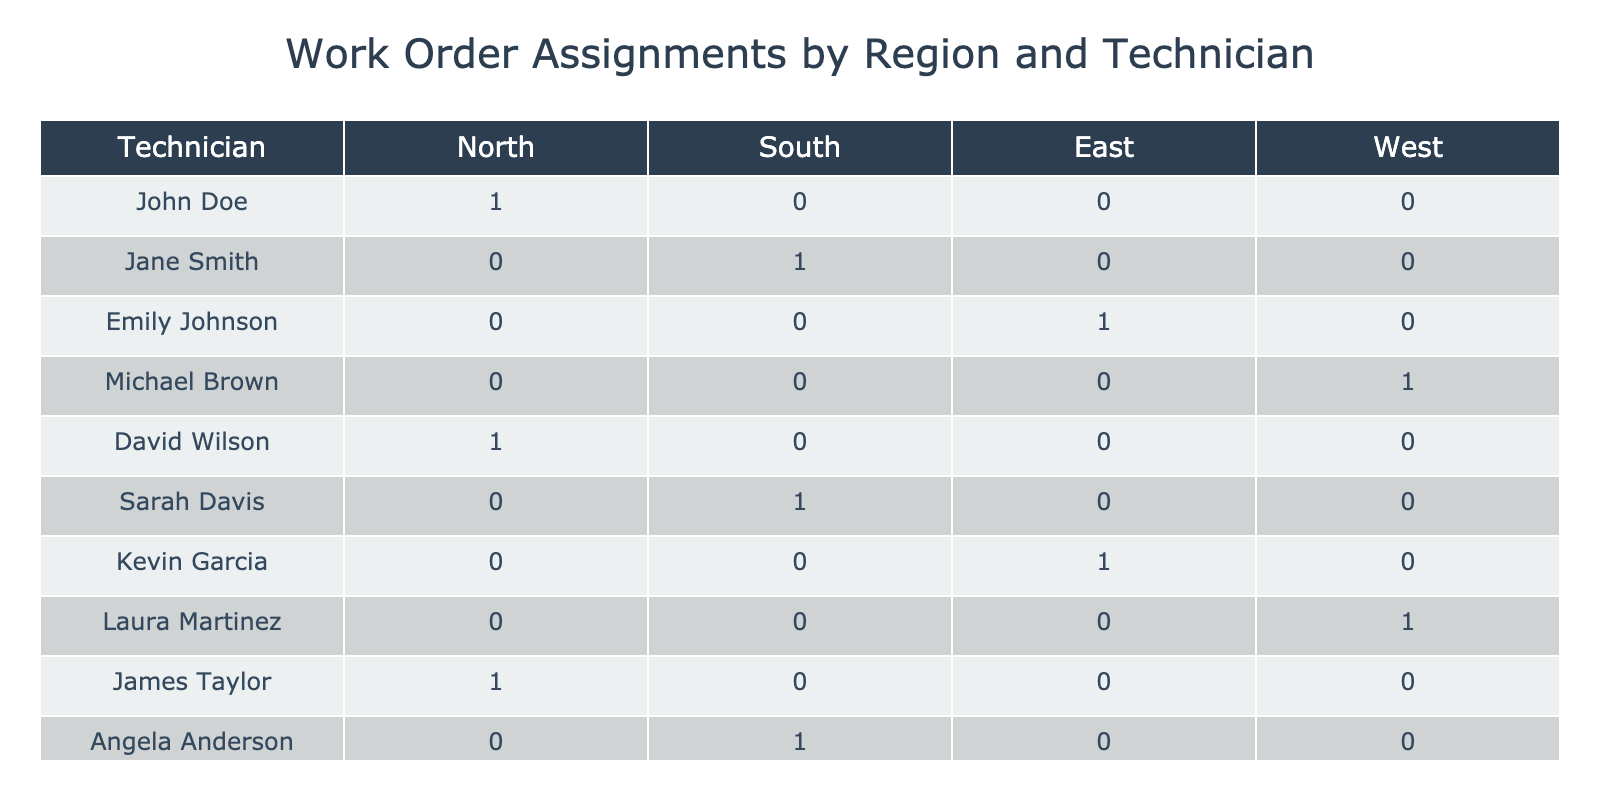What technician was assigned the most work orders? In the table, we can observe the count of work orders assigned to each technician across different regions. John Doe has 3 work orders assigned to him (in North), while others have fewer. Therefore, John Doe has the highest count.
Answer: John Doe How many work orders are currently pending? By reviewing the table, there are three work orders with the status marked as "Pending": one for Emily Johnson, one for Sarah Davis, and one for Angela Anderson. When we count these entries, it confirms that there are three pending work orders.
Answer: 3 Which region has the highest number of completed work orders? Looking at the completed work orders in the table, North has 2 (John Doe, James Taylor), East has 1 (Kevin Garcia), South has 0, and West has 1 (Michael Brown). Hence, the North region has the highest count of completed work orders.
Answer: North Did any technician have work orders in multiple regions? By analyzing the table, John Doe only has work orders in the North, David Wilson in North, Jane Smith in South, and so on, showing each technician has assignments restricted to a single region. Therefore, no technician has work orders in multiple regions.
Answer: No What is the average number of work orders assigned per region? The total number of work orders assigned is 10, with 4 regions represented. To find the average, we calculate 10 divided by 4, which gives us 2.5. Therefore, the average number of work orders per region is 2.5.
Answer: 2.5 What technician has assigned work orders in the South region? By inspecting the table, the technicians with work orders in the South region are Jane Smith and Sarah Davis. Therefore, these two technicians are assigned work orders in the South region.
Answer: Jane Smith, Sarah Davis Which technician has the earliest assigned work order? The earliest date in the table is 2023-10-01 assigned to John Doe. Given that we are only looking for the technician with the very first work order assigned by date, John Doe is the answer.
Answer: John Doe How many work orders does each technician have in total? When we tally the total for each technician based on their work orders assigned in the table: John Doe (3), Jane Smith (1), Emily Johnson (1), Michael Brown (1), David Wilson (2), Sarah Davis (1), Kevin Garcia (1), Laura Martinez (1), James Taylor (1), Angela Anderson (1). This gives us the total counts for each technician.
Answer: John Doe: 3, Jane Smith: 1, Emily Johnson: 1, Michael Brown: 1, David Wilson: 2, Sarah Davis: 1, Kevin Garcia: 1, Laura Martinez: 1, James Taylor: 1, Angela Anderson: 1 